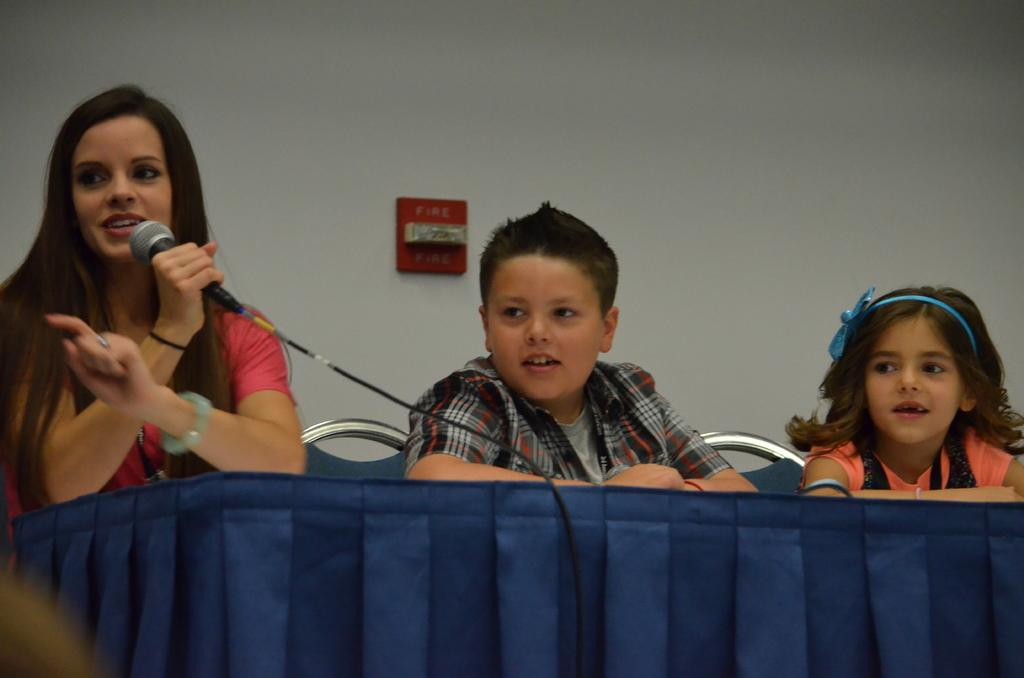Who is the main subject in the image? There is a woman in the image. What is the woman holding in the image? The woman is holding a microphone. What is the woman doing in the image? The woman is speaking. How many children are in the image? There are two children in the image. What are the children doing in the image? The children are sitting on chairs. What is in front of the people in the image? There is a table in front of the people. What can be seen in the background of the image? There is a wall in the background. What type of rod is being used to paste the children's drawings on the wall in the image? There is no rod or children's drawings present in the image. How fast are the people running in the image? There is no running depicted in the image; the woman is speaking and the children are sitting on chairs. 